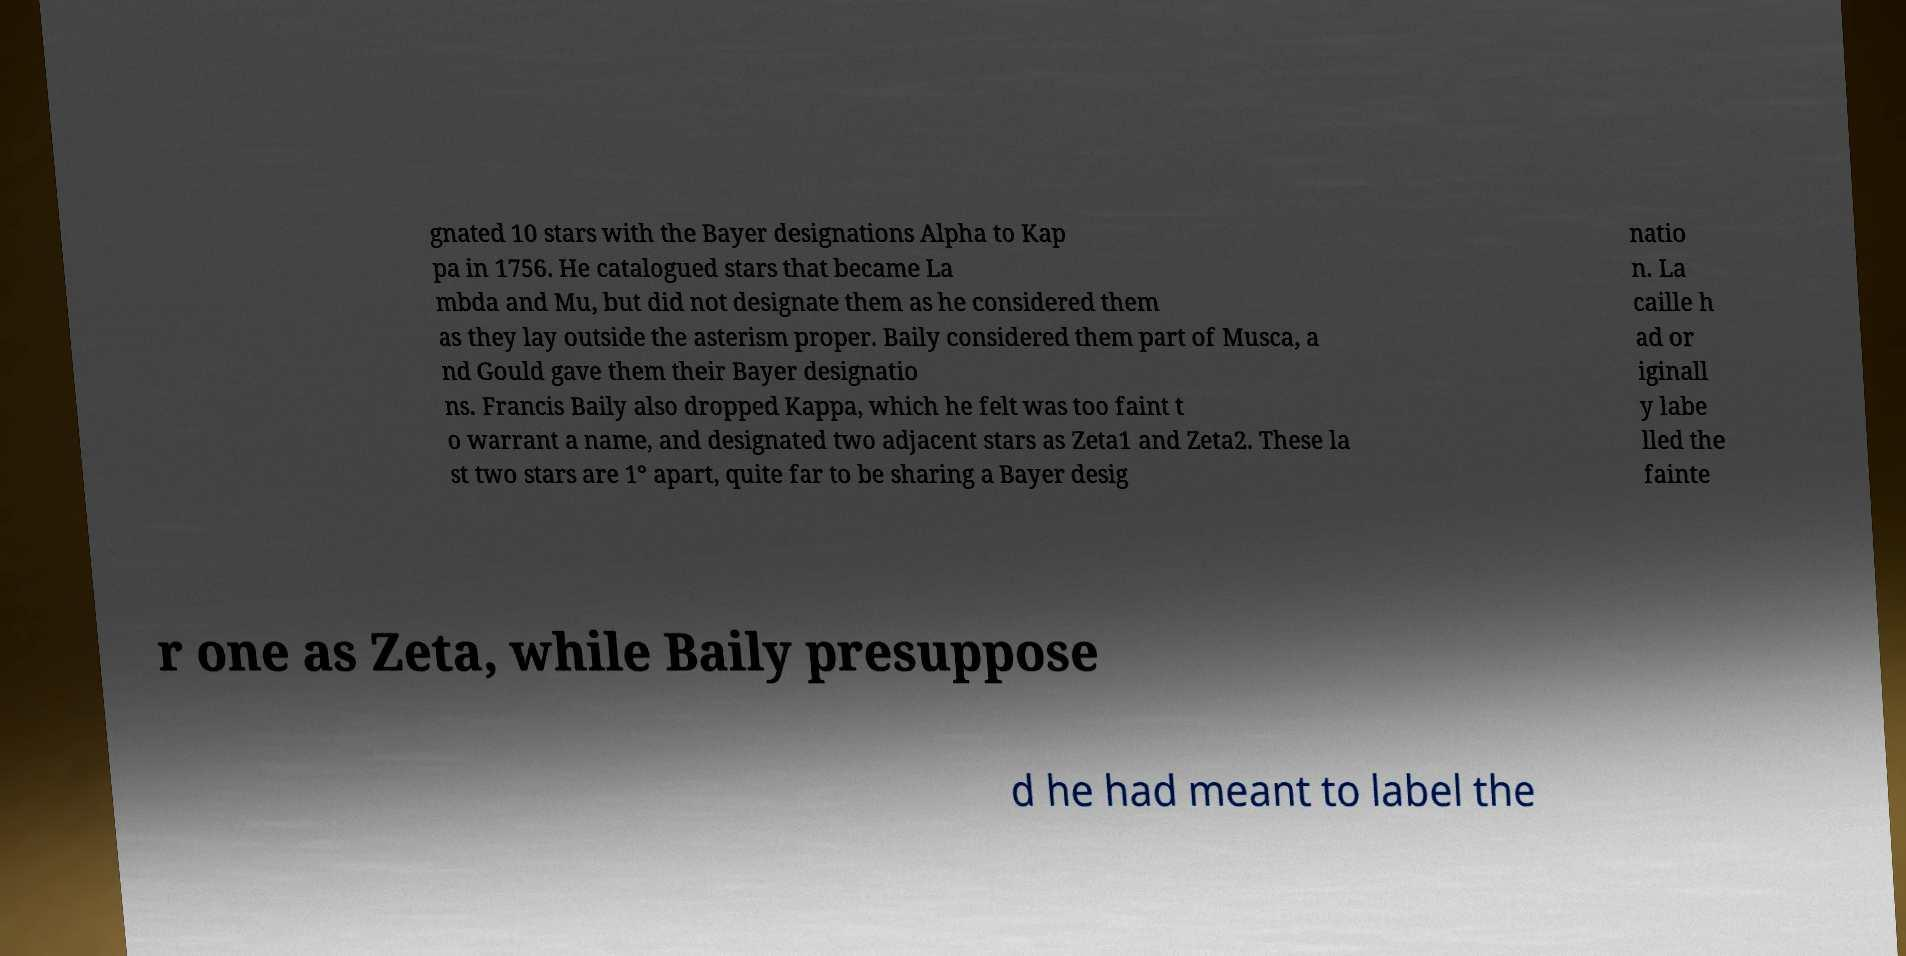Could you assist in decoding the text presented in this image and type it out clearly? gnated 10 stars with the Bayer designations Alpha to Kap pa in 1756. He catalogued stars that became La mbda and Mu, but did not designate them as he considered them as they lay outside the asterism proper. Baily considered them part of Musca, a nd Gould gave them their Bayer designatio ns. Francis Baily also dropped Kappa, which he felt was too faint t o warrant a name, and designated two adjacent stars as Zeta1 and Zeta2. These la st two stars are 1° apart, quite far to be sharing a Bayer desig natio n. La caille h ad or iginall y labe lled the fainte r one as Zeta, while Baily presuppose d he had meant to label the 